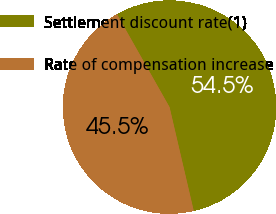Convert chart to OTSL. <chart><loc_0><loc_0><loc_500><loc_500><pie_chart><fcel>Settlement discount rate(1)<fcel>Rate of compensation increase<nl><fcel>54.55%<fcel>45.45%<nl></chart> 